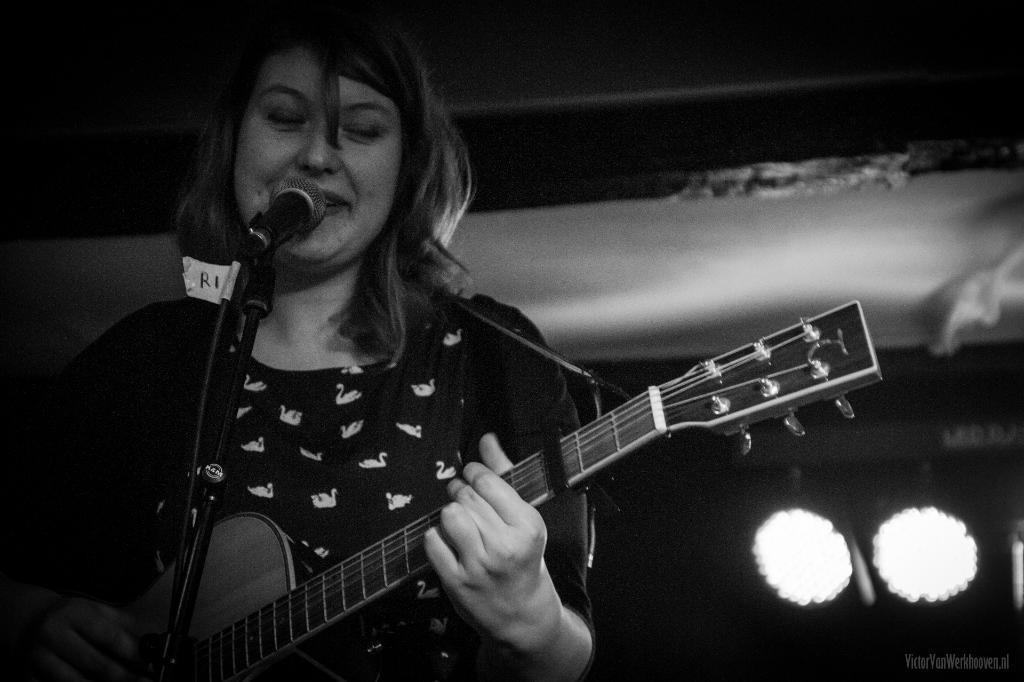Describe this image in one or two sentences. It is a black and white picture where woman is standing and playing a guitar in front of a microphone, behind her there are lights. 